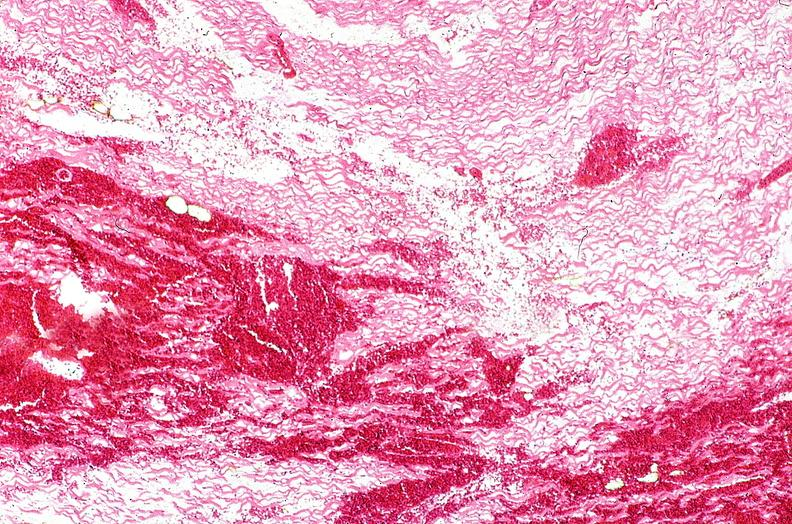s atrophy present?
Answer the question using a single word or phrase. No 